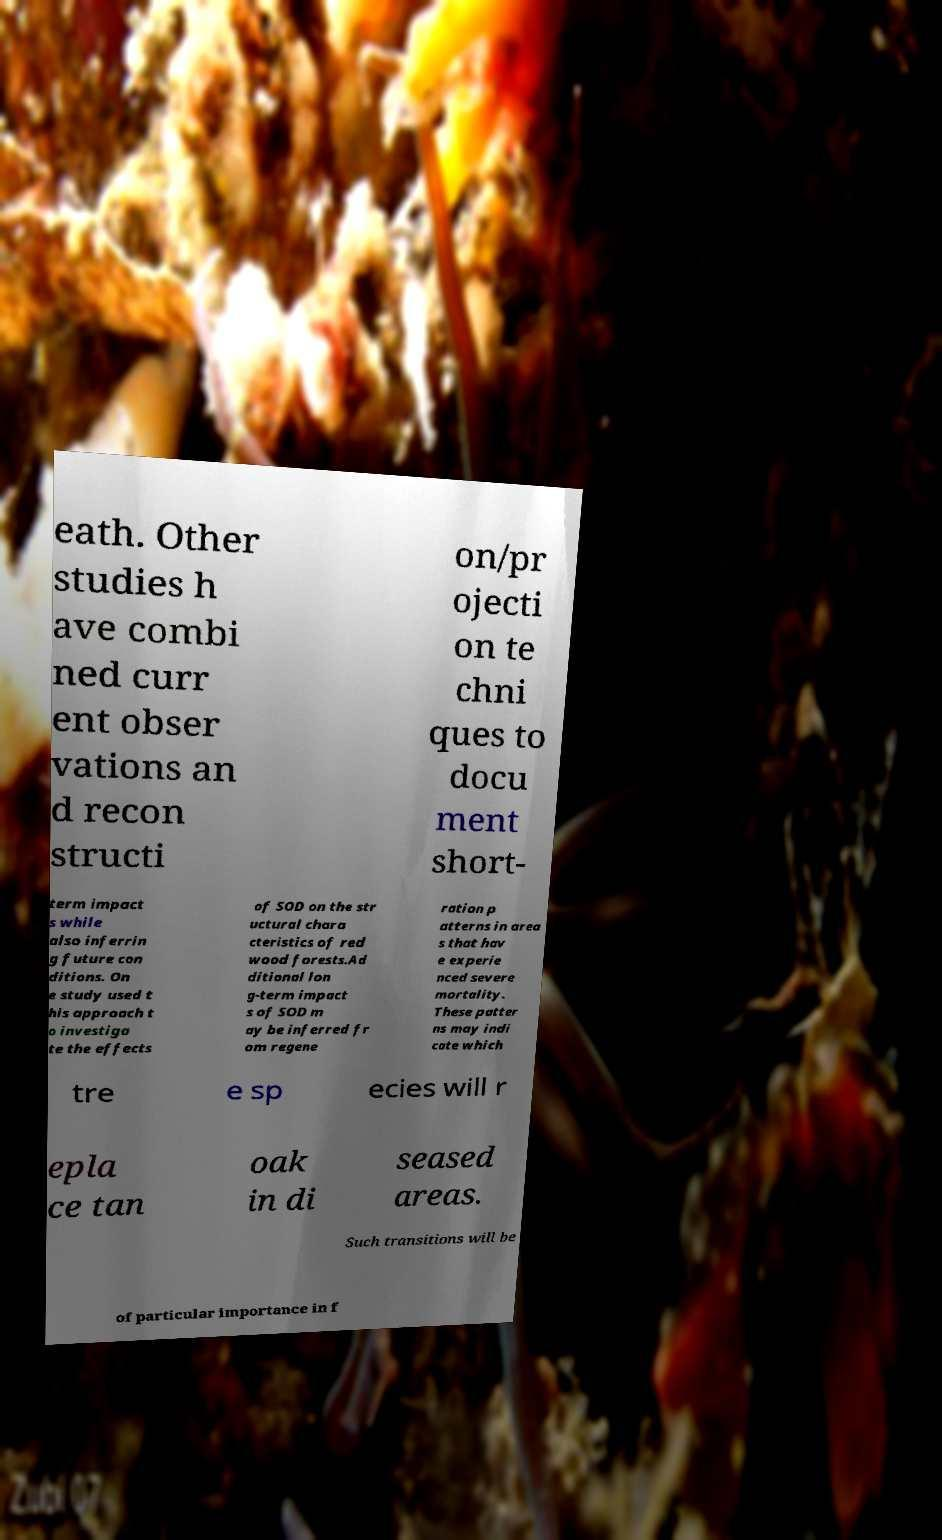Could you extract and type out the text from this image? eath. Other studies h ave combi ned curr ent obser vations an d recon structi on/pr ojecti on te chni ques to docu ment short- term impact s while also inferrin g future con ditions. On e study used t his approach t o investiga te the effects of SOD on the str uctural chara cteristics of red wood forests.Ad ditional lon g-term impact s of SOD m ay be inferred fr om regene ration p atterns in area s that hav e experie nced severe mortality. These patter ns may indi cate which tre e sp ecies will r epla ce tan oak in di seased areas. Such transitions will be of particular importance in f 